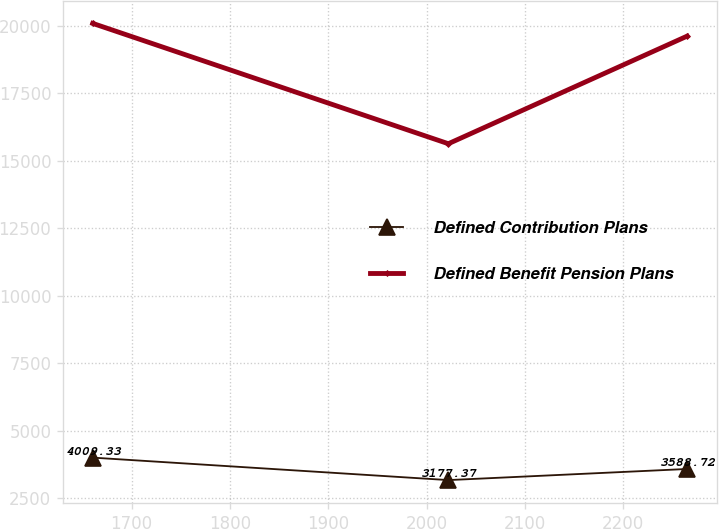Convert chart to OTSL. <chart><loc_0><loc_0><loc_500><loc_500><line_chart><ecel><fcel>Defined Contribution Plans<fcel>Defined Benefit Pension Plans<nl><fcel>1660.54<fcel>4009.33<fcel>20084.6<nl><fcel>2022.09<fcel>3177.37<fcel>15630<nl><fcel>2264.79<fcel>3588.72<fcel>19612<nl></chart> 